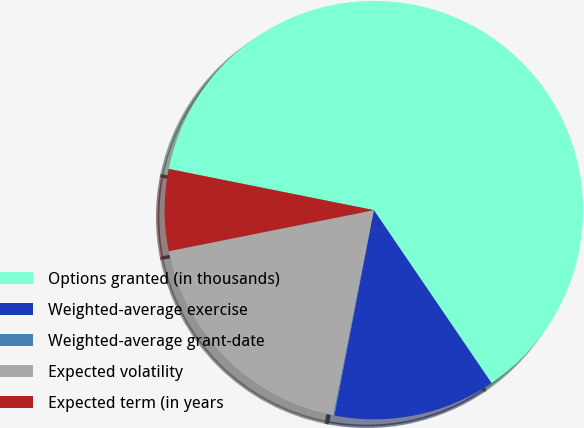<chart> <loc_0><loc_0><loc_500><loc_500><pie_chart><fcel>Options granted (in thousands)<fcel>Weighted-average exercise<fcel>Weighted-average grant-date<fcel>Expected volatility<fcel>Expected term (in years<nl><fcel>62.33%<fcel>12.53%<fcel>0.08%<fcel>18.75%<fcel>6.3%<nl></chart> 